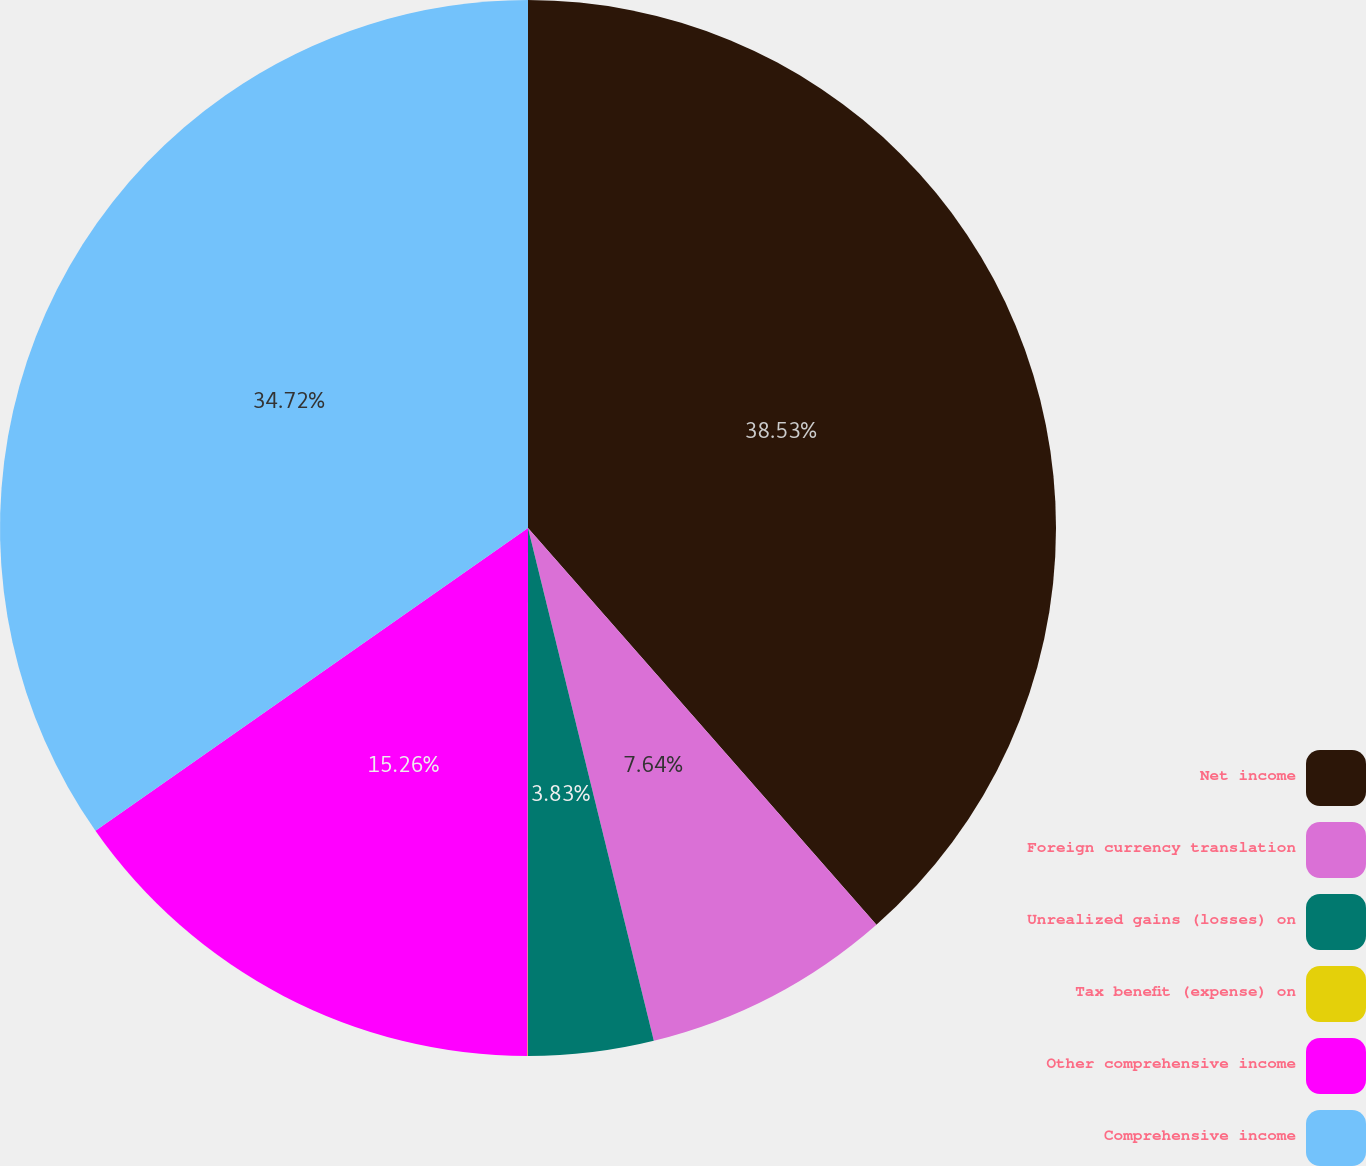<chart> <loc_0><loc_0><loc_500><loc_500><pie_chart><fcel>Net income<fcel>Foreign currency translation<fcel>Unrealized gains (losses) on<fcel>Tax benefit (expense) on<fcel>Other comprehensive income<fcel>Comprehensive income<nl><fcel>38.53%<fcel>7.64%<fcel>3.83%<fcel>0.02%<fcel>15.26%<fcel>34.72%<nl></chart> 